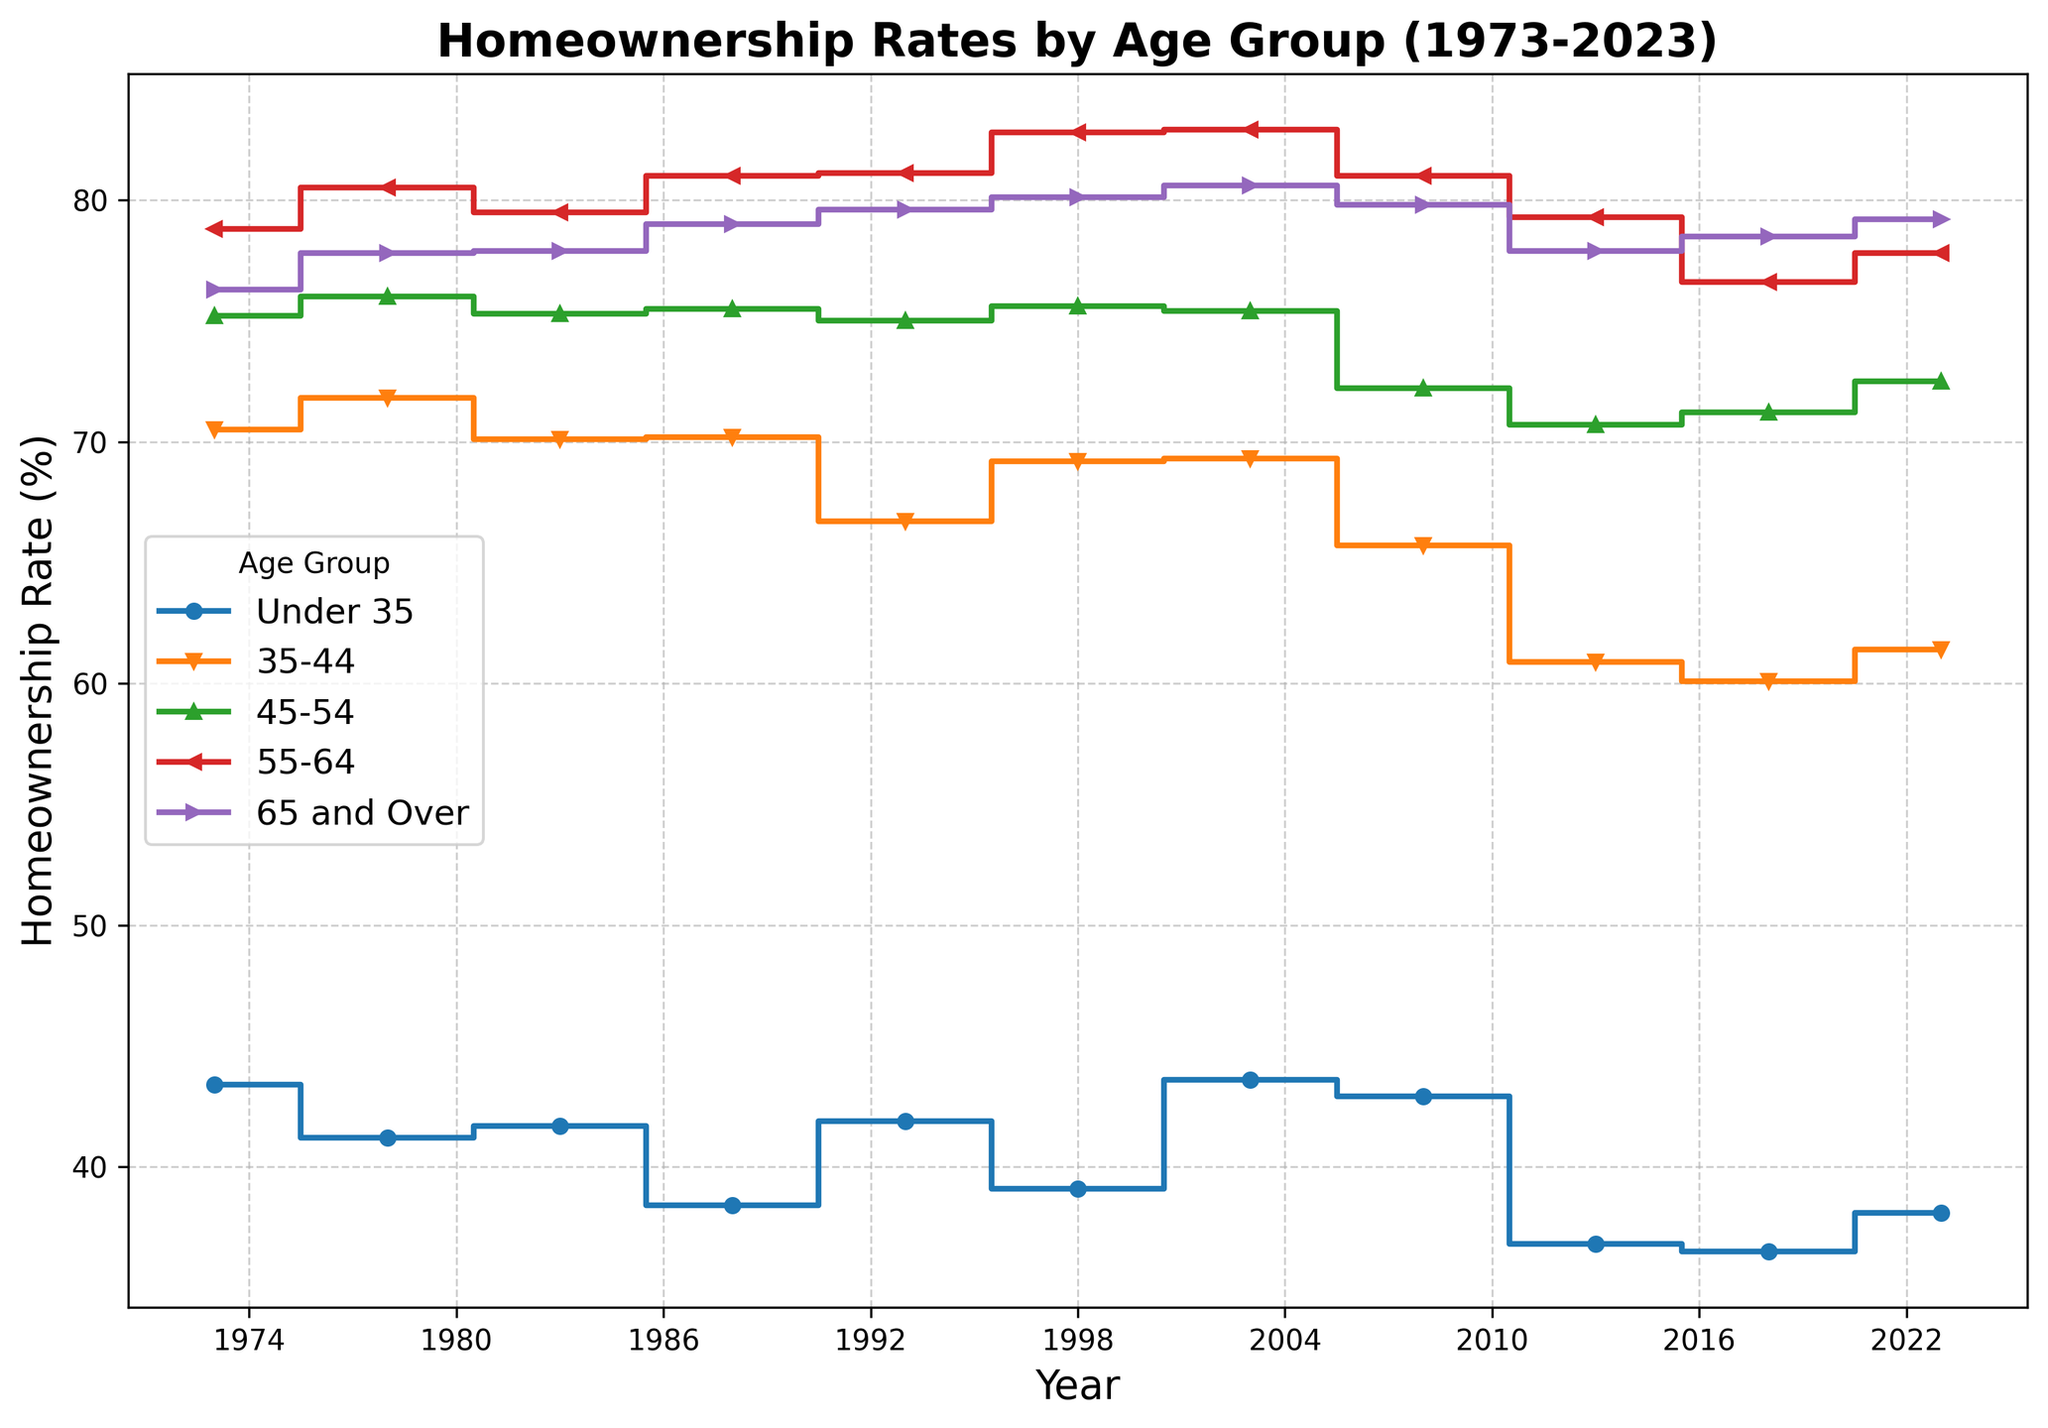What's the trend for homeownership rates for the age group "Under 35" over the past 50 years? The graph shows a general decline in homeownership rates for the "Under 35" age group from 43.4% in 1973 to 38.1% in 2023. While there were some fluctuations, the overall trend is downward.
Answer: Declining trend Which age group had the highest homeownership rate in 2023? In 2023, the "65 and Over" age group had the highest homeownership rate. This can be observed as their line is the topmost across all age groups in that year, ending at 79.2%.
Answer: 65 and Over How did the homeownership rate for the "35-44" age group change between 1988 and 2013? In 1988, the homeownership rate for the "35-44" age group was 70.2%. By 2013, it had decreased to 60.9%. The change in value is 70.2% - 60.9% = 9.3%.
Answer: Decreased by 9.3% Compare the homeownership rates of the "45-54" and "55-64" age groups in 1998 and determine which group had a higher rate and by how much. In 1998, the homeownership rate for the "45-54" age group was 75.6%, and for the "55-64" age group, it was 82.8%. The "55-64" age group had a higher rate by 82.8% - 75.6% = 7.2%.
Answer: 55-64 by 7.2% What are the homeownership rates consistently above 80% for the "55-64" age group from 1998 to 2023? The graph shows that the homeownership rates for the "55-64" age group were consistently above 80% from 1998 (82.8%) to 2023 (77.8%), except for a slight dip to 79.3% in 2008 and another to 76.6% in 2018.
Answer: True with dips What is the overall trend for homeownership rates in the "65 and Over" age group over the last 50 years? The "65 and Over" age group shows a gradually increasing trend in homeownership rates over the past 50 years, increasing from 76.3% in 1973 to 79.2% in 2023. While the trend shows minor fluctuations, it's generally upward.
Answer: Increasing trend How does the homeownership rate in 2003 for "Under 35" compare to its rate in 1973, and by what percentage did it change? In 1973, the "Under 35" homeownership rate was 43.4%, and in 2003, it was 43.6%. The difference is 43.6% - 43.4% = 0.2%, showing an increase of approximately 0.46%.
Answer: Increased by 0.46% Between which years did the "55-64" age group see the largest decline in homeownership rates? The "55-64" age group saw the largest decline in homeownership rates between 2003 and 2013, dropping from 82.9% to 79.3%.
Answer: 2003 to 2013 What visual features indicate the homeownership rate for different age groups? The figure uses different step lines with distinct colors and markers for each age group to represent homeownership rates. Colors and shapes distinguish different groups visually, with legends indicating which line represents which age group.
Answer: Colors and markers 